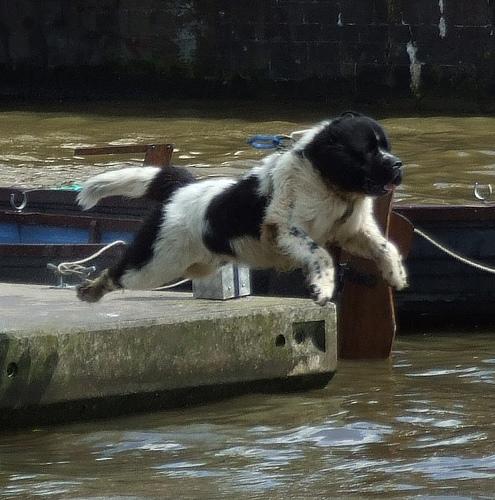What is the dog doing?
Short answer required. Jumping into water. What is the dog jumping into?
Concise answer only. Water. Will the dog get wet?
Answer briefly. Yes. 